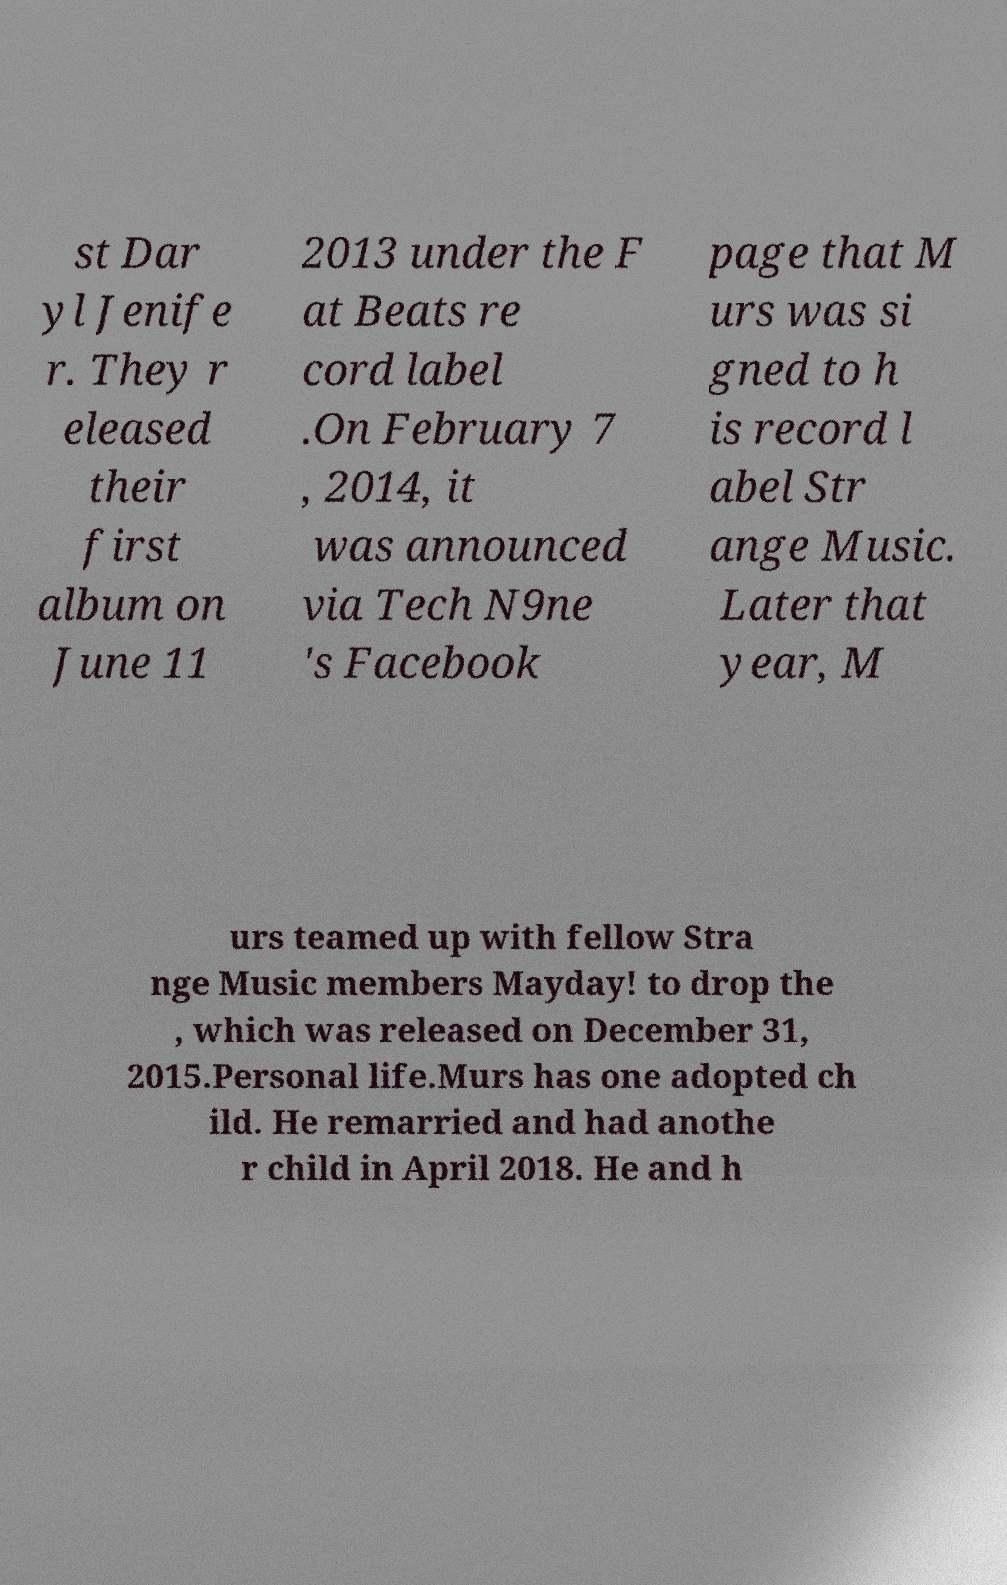What messages or text are displayed in this image? I need them in a readable, typed format. st Dar yl Jenife r. They r eleased their first album on June 11 2013 under the F at Beats re cord label .On February 7 , 2014, it was announced via Tech N9ne 's Facebook page that M urs was si gned to h is record l abel Str ange Music. Later that year, M urs teamed up with fellow Stra nge Music members Mayday! to drop the , which was released on December 31, 2015.Personal life.Murs has one adopted ch ild. He remarried and had anothe r child in April 2018. He and h 